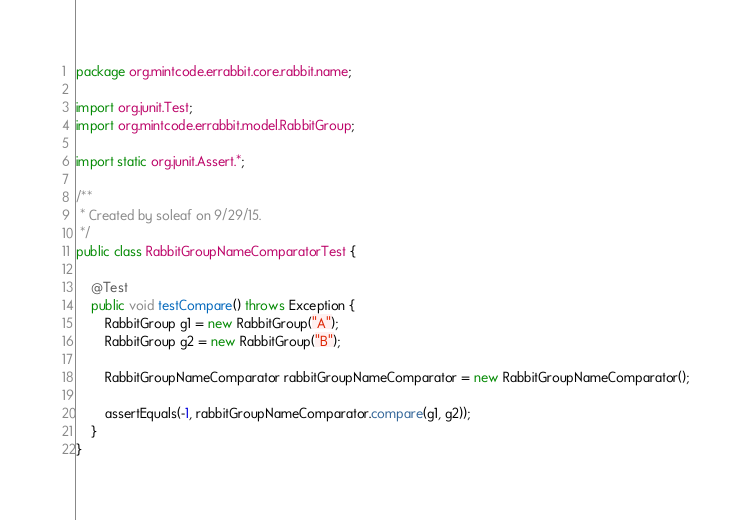Convert code to text. <code><loc_0><loc_0><loc_500><loc_500><_Java_>package org.mintcode.errabbit.core.rabbit.name;

import org.junit.Test;
import org.mintcode.errabbit.model.RabbitGroup;

import static org.junit.Assert.*;

/**
 * Created by soleaf on 9/29/15.
 */
public class RabbitGroupNameComparatorTest {

    @Test
    public void testCompare() throws Exception {
        RabbitGroup g1 = new RabbitGroup("A");
        RabbitGroup g2 = new RabbitGroup("B");

        RabbitGroupNameComparator rabbitGroupNameComparator = new RabbitGroupNameComparator();

        assertEquals(-1, rabbitGroupNameComparator.compare(g1, g2));
    }
}</code> 